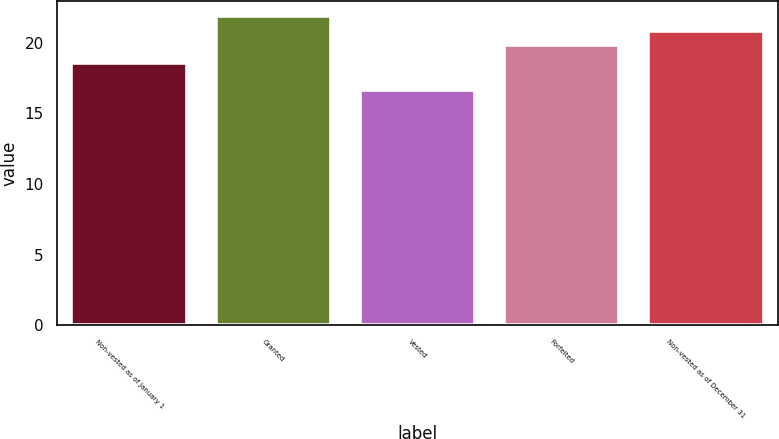Convert chart to OTSL. <chart><loc_0><loc_0><loc_500><loc_500><bar_chart><fcel>Non-vested as of January 1<fcel>Granted<fcel>Vested<fcel>Forfeited<fcel>Non-vested as of December 31<nl><fcel>18.53<fcel>21.87<fcel>16.64<fcel>19.8<fcel>20.84<nl></chart> 